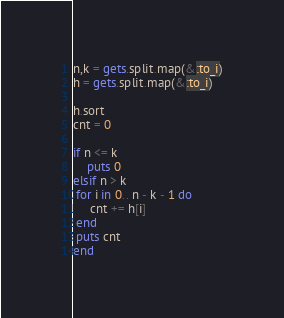<code> <loc_0><loc_0><loc_500><loc_500><_Ruby_>n,k = gets.split.map(&:to_i)
h = gets.split.map(&:to_i)

h.sort
cnt = 0

if n <= k
    puts 0
elsif n > k
 for i in 0.. n - k - 1 do
     cnt += h[i]
 end
 puts cnt 
end
</code> 